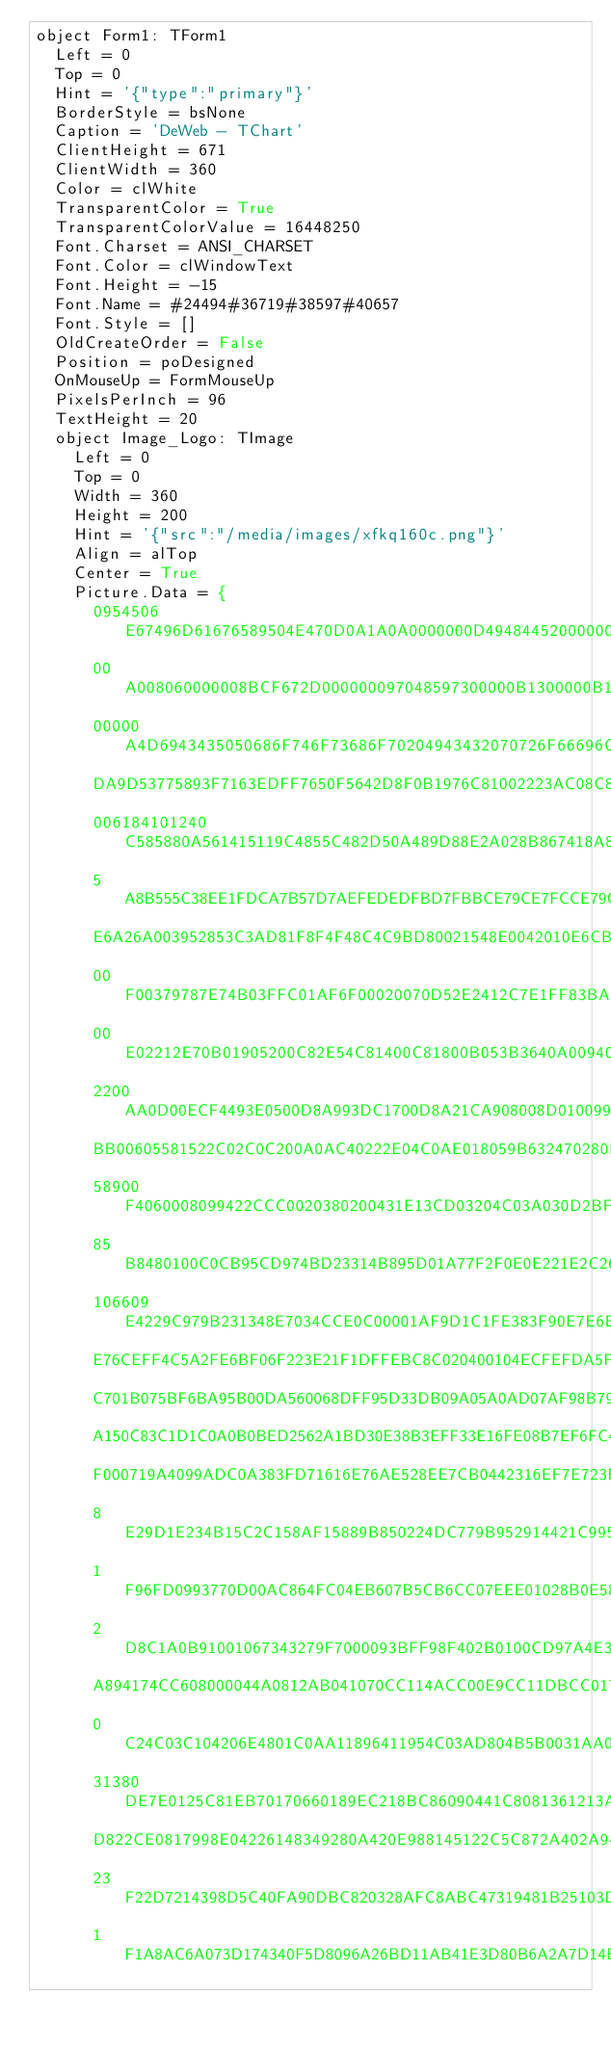Convert code to text. <code><loc_0><loc_0><loc_500><loc_500><_Pascal_>object Form1: TForm1
  Left = 0
  Top = 0
  Hint = '{"type":"primary"}'
  BorderStyle = bsNone
  Caption = 'DeWeb - TChart'
  ClientHeight = 671
  ClientWidth = 360
  Color = clWhite
  TransparentColor = True
  TransparentColorValue = 16448250
  Font.Charset = ANSI_CHARSET
  Font.Color = clWindowText
  Font.Height = -15
  Font.Name = #24494#36719#38597#40657
  Font.Style = []
  OldCreateOrder = False
  Position = poDesigned
  OnMouseUp = FormMouseUp
  PixelsPerInch = 96
  TextHeight = 20
  object Image_Logo: TImage
    Left = 0
    Top = 0
    Width = 360
    Height = 200
    Hint = '{"src":"/media/images/xfkq160c.png"}'
    Align = alTop
    Center = True
    Picture.Data = {
      0954506E67496D61676589504E470D0A1A0A0000000D49484452000000A00000
      00A008060000008BCF672D000000097048597300000B1300000B1301009A9C18
      00000A4D6943435050686F746F73686F70204943432070726F66696C65000078
      DA9D53775893F7163EDFF7650F5642D8F0B1976C81002223AC08C81059A21092
      006184101240C585880A561415119C4855C482D50A489D88E2A028B867418A88
      5A8B555C38EE1FDCA7B57D7AEFEDEDFBD7FBBCE79CE7FCCE79CF0F8011122691
      E6A26A003952853C3AD81F8F4F48C4C9BD80021548E0042010E6CBC26705C500
      00F00379787E74B03FFC01AF6F00020070D52E2412C7E1FF83BA502657002091
      00E02212E70B01905200C82E54C81400C81800B053B3640A009400006C797C42
      2200AA0D00ECF4493E0500D8A993DC1700D8A21CA908008D0100992847240240
      BB00605581522C02C0C200A0AC40222E04C0AE018059B632470280BD0500768E
      58900F4060008099422CCC0020380200431E13CD03204C03A030D2BFE0A95F70
      85B8480100C0CB95CD974BD23314B895D01A77F2F0E0E221E2C26CB142611729
      106609E4229C979B231348E7034CCE0C00001AF9D1C1FE383F90E7E6E4E1E666
      E76CEFF4C5A2FE6BF06F223E21F1DFFEBC8C020400104ECFEFDA5FE5E5D60370
      C701B075BF6BA95B00DA560068DFF95D33DB09A05A0AD07AF98B7938FC401E9E
      A150C83C1D1C0A0B0BED2562A1BD30E38B3EFF33E16FE08B7EF6FC401EFEDB7A
      F000719A4099ADC0A383FD71616E76AE528EE7CB0442316EF7E723FEC7857FFD
      8E29D1E234B15C2C158AF15889B850224DC779B952914421C995E212E97F32F1
      1F96FD0993770D00AC864FC04EB607B5CB6CC07EEE01028B0E58D27600407EF3
      2D8C1A0B91001067343279F7000093BFF98F402B0100CD97A4E30000BCE8185C
      A894174CC608000044A0812AB041070CC114ACC00E9CC11DBCC0170261064440
      0C24C03C104206E4801C0AA11896411954C03AD804B5B0031AA0119AE110B4C1
      31380DE7E0125C81EB70170660189EC218BC86090441C8081361213A8811628E
      D822CE0817998E04226148349280A420E988145122C5C872A402A9426A915D48
      23F22D7214398D5C40FA90DBC820328AFC8ABC47319481B25103D4027540B9A8
      1F1A8AC6A073D174340F5D8096A26BD11AB41E3D80B6A2A7D14BE87574007D8A</code> 